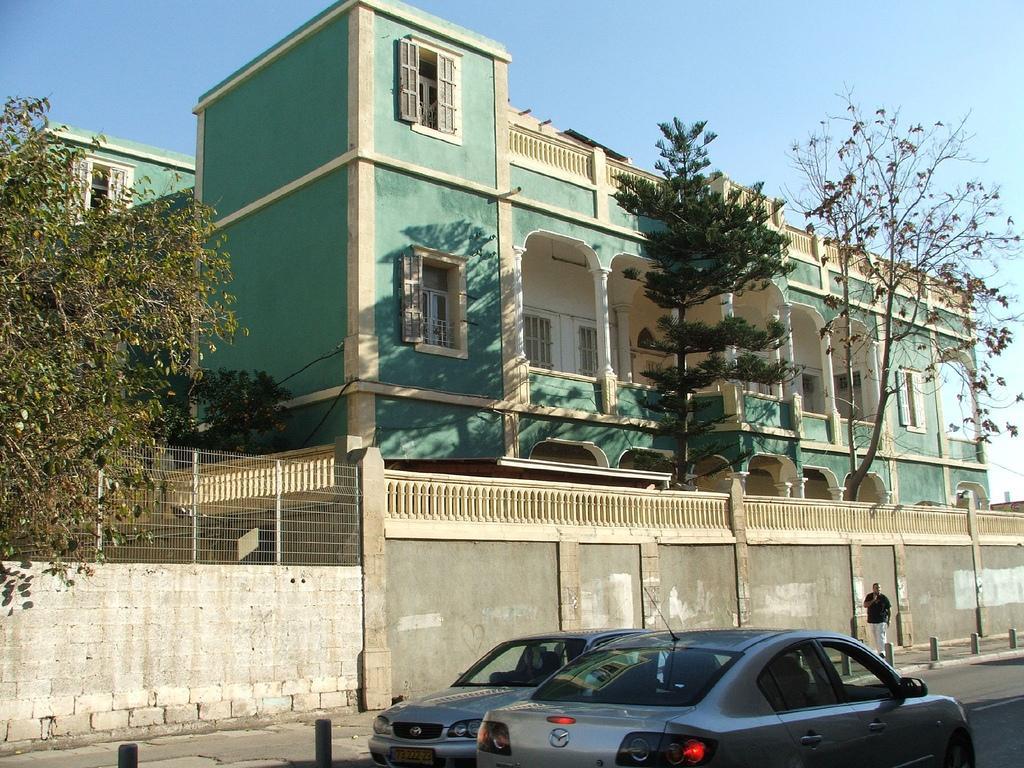In one or two sentences, can you explain what this image depicts? As we can see in the image there are buildings, trees, fence, cars, a person walking over here and sky. 